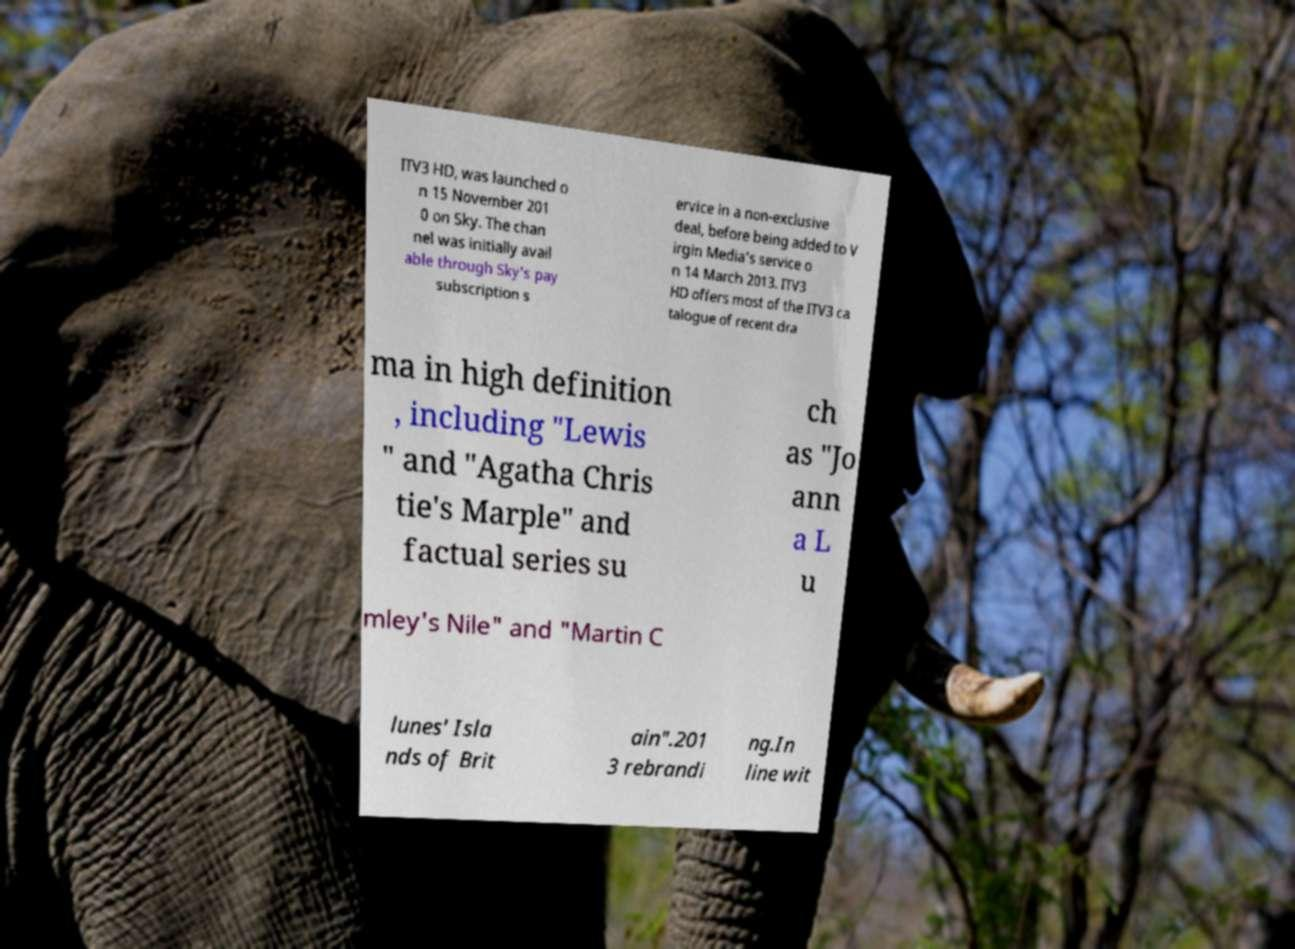Please read and relay the text visible in this image. What does it say? ITV3 HD, was launched o n 15 November 201 0 on Sky. The chan nel was initially avail able through Sky's pay subscription s ervice in a non-exclusive deal, before being added to V irgin Media's service o n 14 March 2013. ITV3 HD offers most of the ITV3 ca talogue of recent dra ma in high definition , including "Lewis " and "Agatha Chris tie's Marple" and factual series su ch as "Jo ann a L u mley's Nile" and "Martin C lunes' Isla nds of Brit ain".201 3 rebrandi ng.In line wit 